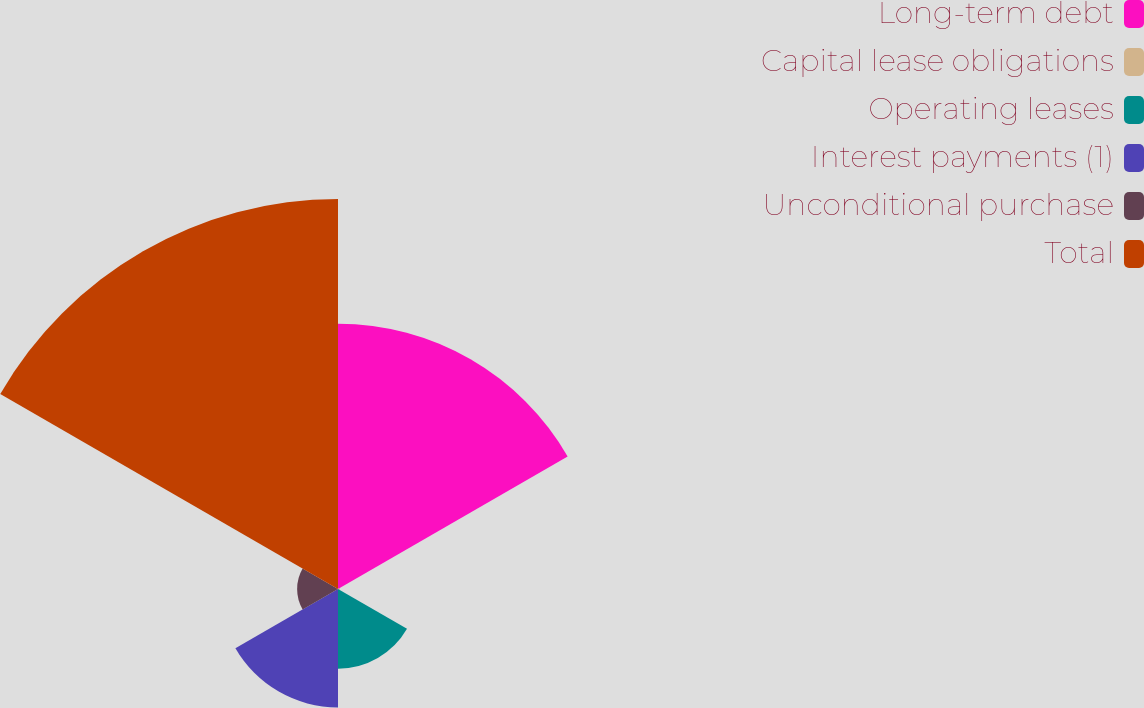Convert chart to OTSL. <chart><loc_0><loc_0><loc_500><loc_500><pie_chart><fcel>Long-term debt<fcel>Capital lease obligations<fcel>Operating leases<fcel>Interest payments (1)<fcel>Unconditional purchase<fcel>Total<nl><fcel>29.59%<fcel>0.23%<fcel>8.89%<fcel>13.22%<fcel>4.56%<fcel>43.52%<nl></chart> 